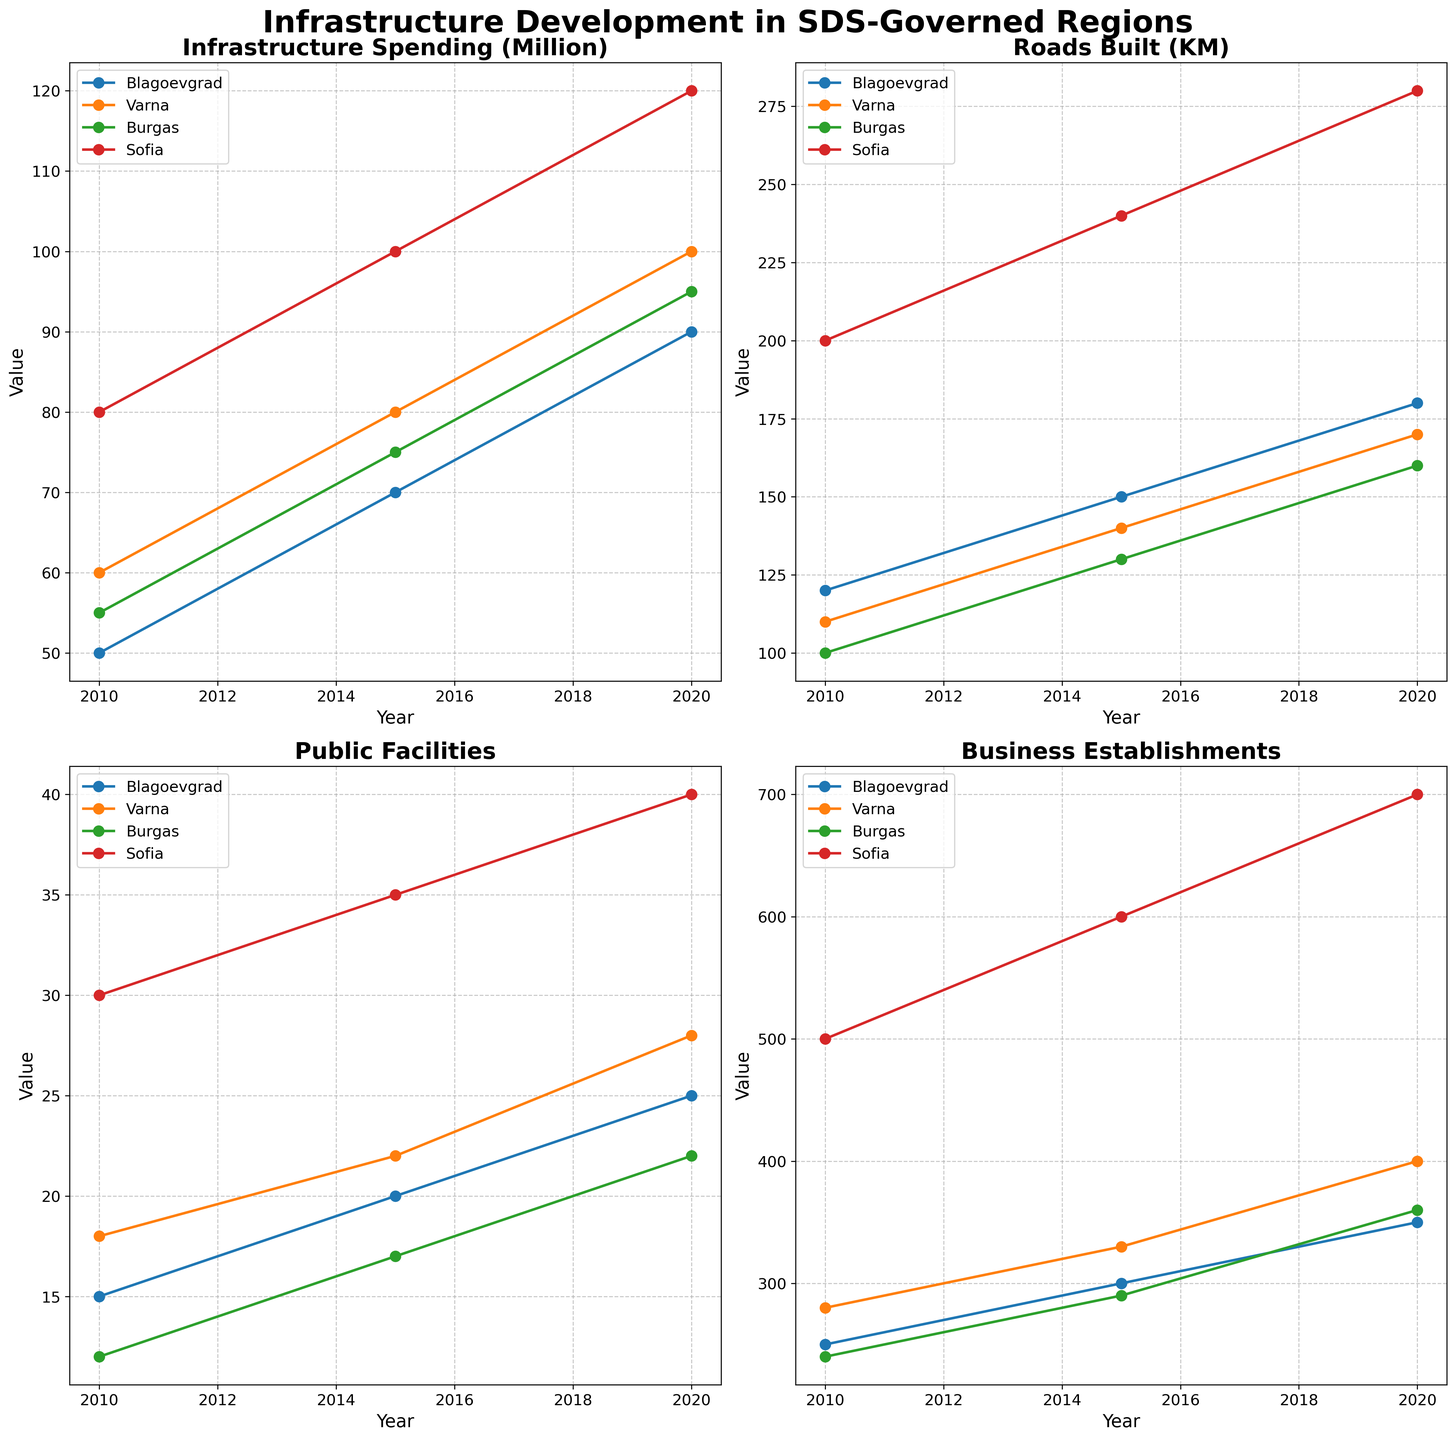What is the title of the figure? The title is prominently displayed at the top of the figure, providing an overview of what the plots represent.
Answer: "Infrastructure Development in SDS-Governed Regions" How many subplots are there in the figure? The figure is divided into equal sections which contain smaller plots for different metrics.
Answer: 4 Which region shows the highest increase in Business Establishments from 2010 to 2020? Look at the subplot for Business Establishments and compare the lines. The steepest upward trend indicates the highest increase.
Answer: Sofia What is the overall trend of Infrastructure Spending in the region of Varna? Look at the line corresponding to Varna in the Infrastructure Spending subplot and note its direction from 2010 to 2020.
Answer: Increasing Which metric shows the most significant change in Sofia from 2010 to 2020? Compare the slopes of the lines in all subplots to see which one changes the most dramatically for Sofia.
Answer: Built Roads (KM) Which region had the most consistent development in Public Facilities from 2010 to 2020? Look at the smoothness and stability of each region's line in the Public Facilities subplot. The line that has the least variation is the most consistent.
Answer: Burgas Is there any region where the amount of infrastructure spending didn't increase between any two consecutive recorded years? Examine the Infrastructure Spending subplot for any flat lines (no increase) in any of the regions.
Answer: No Which region had the least growth in Built Roads (KM) between 2010 and 2015? Look at the Built Roads (KM) subplot and find the region with the smallest difference between 2010 and 2015.
Answer: Burgas How does the trend in Public Facilities in Blagoevgrad compare to that of Burgas? Compare the lines for Blagoevgrad and Burgas in the Public Facilities subplot to see if one is higher, lower, or similar.
Answer: Blagoevgrad shows a steeper increase than Burgas 